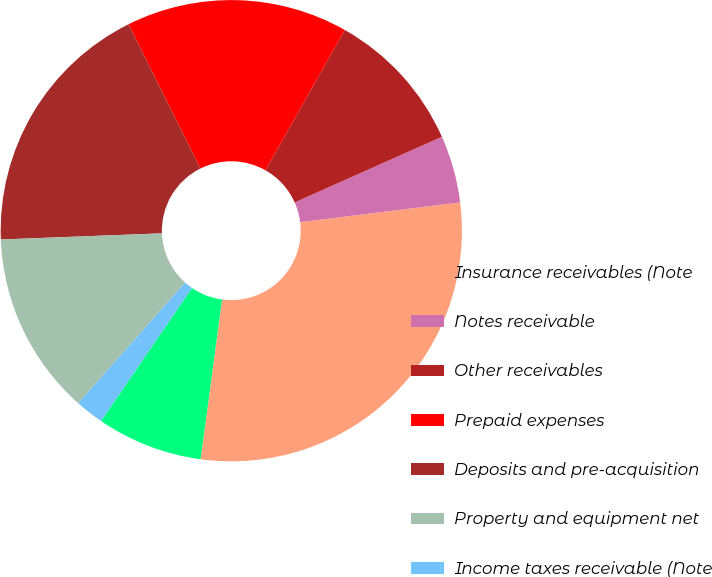Convert chart. <chart><loc_0><loc_0><loc_500><loc_500><pie_chart><fcel>Insurance receivables (Note<fcel>Notes receivable<fcel>Other receivables<fcel>Prepaid expenses<fcel>Deposits and pre-acquisition<fcel>Property and equipment net<fcel>Income taxes receivable (Note<fcel>Other<nl><fcel>29.08%<fcel>4.72%<fcel>10.13%<fcel>15.55%<fcel>18.25%<fcel>12.84%<fcel>2.01%<fcel>7.42%<nl></chart> 